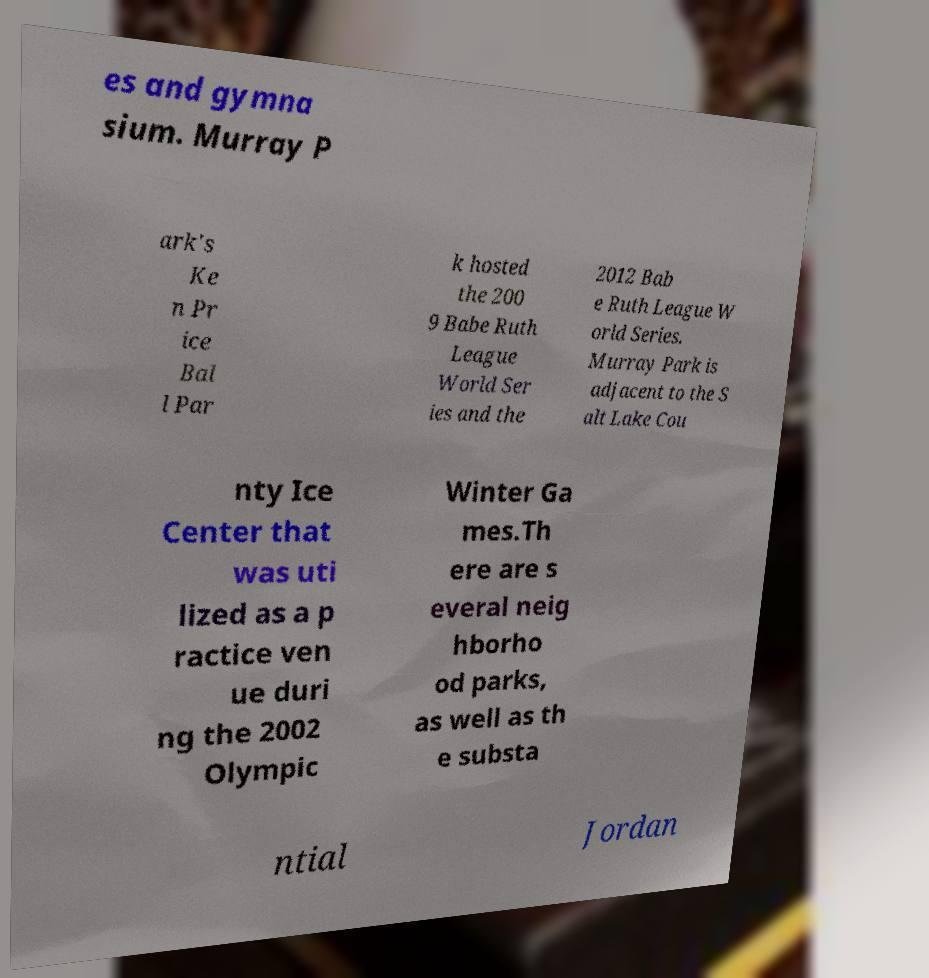Could you extract and type out the text from this image? es and gymna sium. Murray P ark's Ke n Pr ice Bal l Par k hosted the 200 9 Babe Ruth League World Ser ies and the 2012 Bab e Ruth League W orld Series. Murray Park is adjacent to the S alt Lake Cou nty Ice Center that was uti lized as a p ractice ven ue duri ng the 2002 Olympic Winter Ga mes.Th ere are s everal neig hborho od parks, as well as th e substa ntial Jordan 